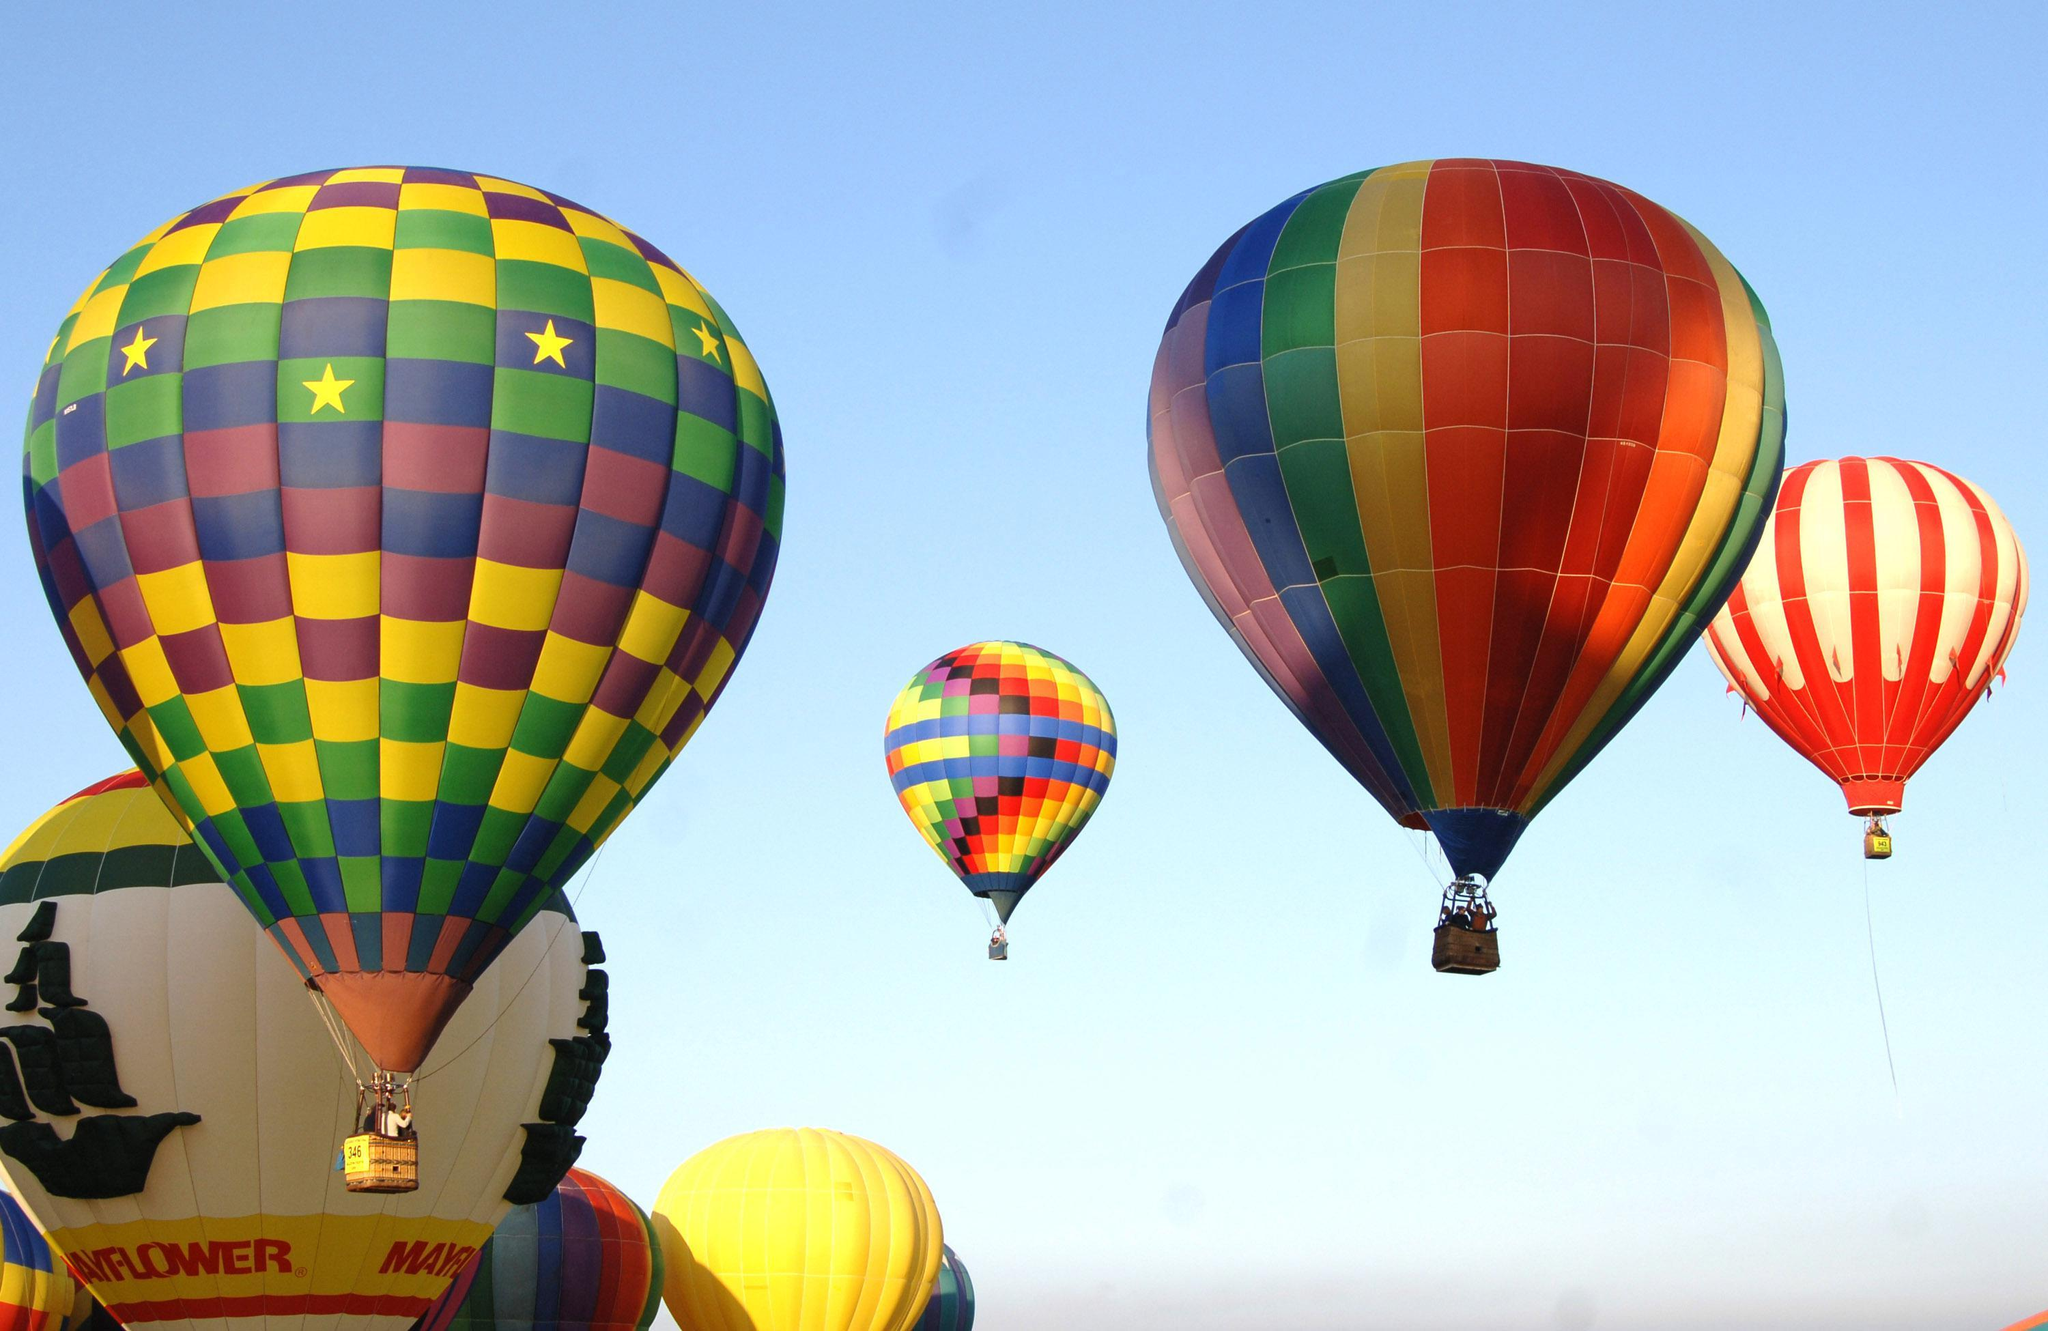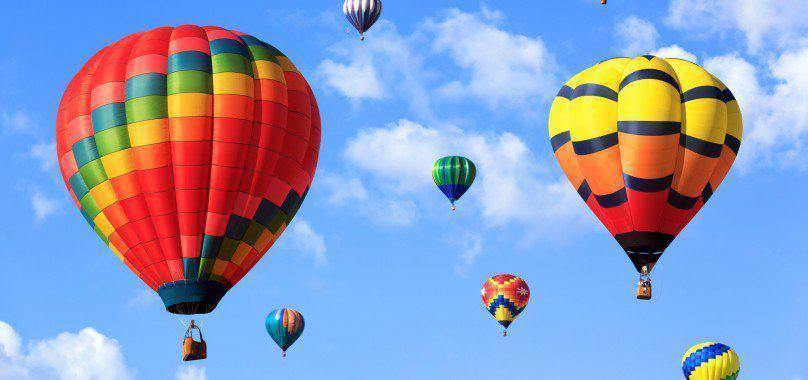The first image is the image on the left, the second image is the image on the right. Analyze the images presented: Is the assertion "An image shows just one multi-colored balloon against a cloudless sky." valid? Answer yes or no. No. The first image is the image on the left, the second image is the image on the right. Given the left and right images, does the statement "there are exactly seven balloons in the image on the right" hold true? Answer yes or no. Yes. 